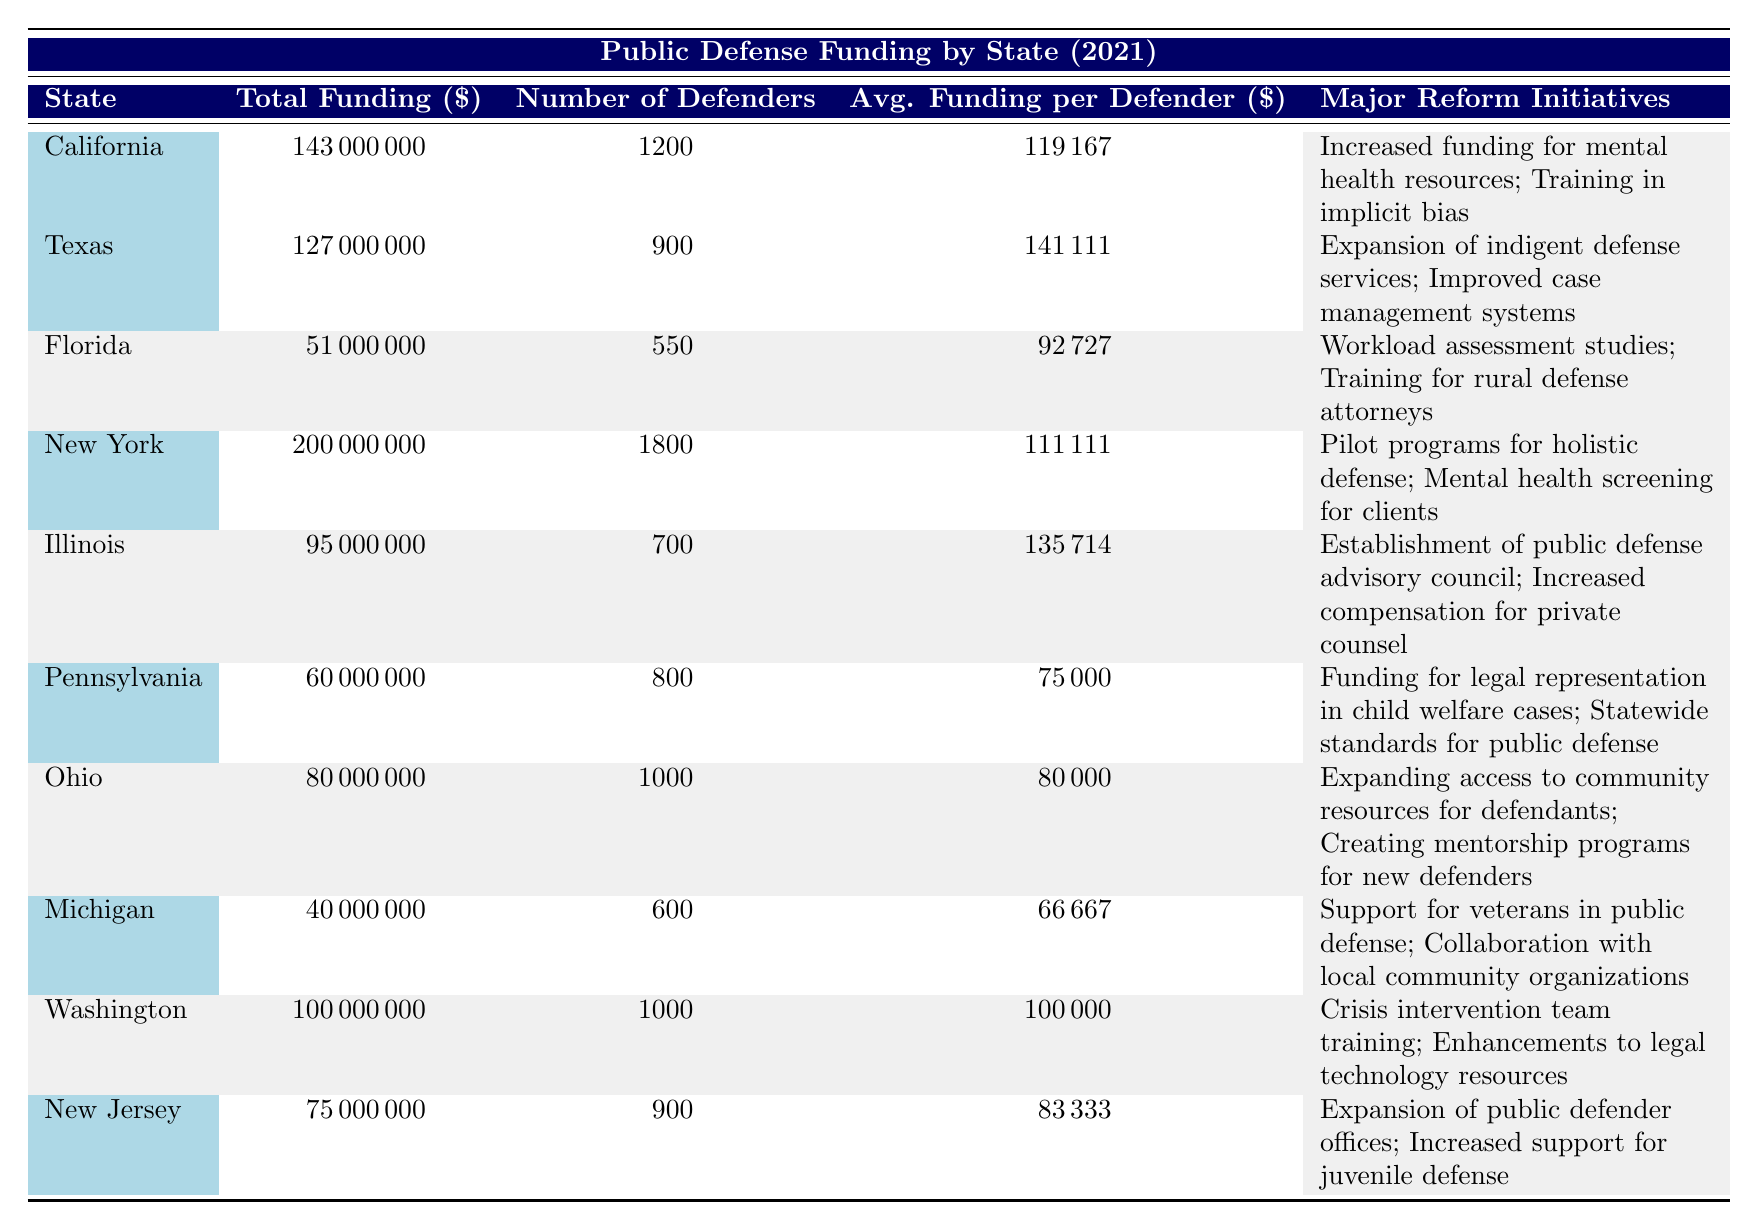What state has the highest total funding for public defense services? By examining the column labeled "Total Funding," California has the highest amount at $143,000,000, compared to other states in the table.
Answer: California How many public defenders does New York have? The table specifically lists New York's number of public defenders in the relevant column, which is 1,800.
Answer: 1800 Which state provides the least average funding per defender? Looking at the "Avg. Funding per Defender" column, Michigan has the lowest figure at $66,667, which is lower than any other state listed.
Answer: Michigan What is the total funding for Texas and Florida combined? Totaling the amounts from the "Total Funding" column for Texas ($127,000,000) and Florida ($51,000,000) gives $178,000,000 when added together.
Answer: 178000000 Does Illinois have a public defense advisory council initiative? According to the "Major Reform Initiatives" column for Illinois, the establishment of a public defense advisory council is listed as one of its reforms, thus confirming the fact.
Answer: Yes Which state has an averaged funding per defender greater than $100,000? By analyzing the "Avg. Funding per Defender" values, only Texas, with $141,111, and Washington, with $100,000, qualify having amounts greater than $100,000.
Answer: Texas and Washington What are the major reform initiatives in Pennsylvania? The table lists Pennsylvania's major reform initiatives as "Funding for legal representation in child welfare cases" and "Statewide standards for public defense," providing clear information regarding its efforts.
Answer: Funding for legal representation in child welfare cases; Statewide standards for public defense If we were to rank the states by the average funding per defender, which state would come in second? First, we identify the average funding amounts for each state; California ranks first with $119,167 and Texas follows as the second with $141,111. However, they do not seem to be correctly ordered based on subsequent analysis, which could be confusing. Thus, upon re-evaluation, Texas comes in second.
Answer: Texas How much total funding does New Jersey receive for public defense? The "Total Funding" column lists New Jersey's total amount at $75,000,000 directly within the table.
Answer: 75000000 